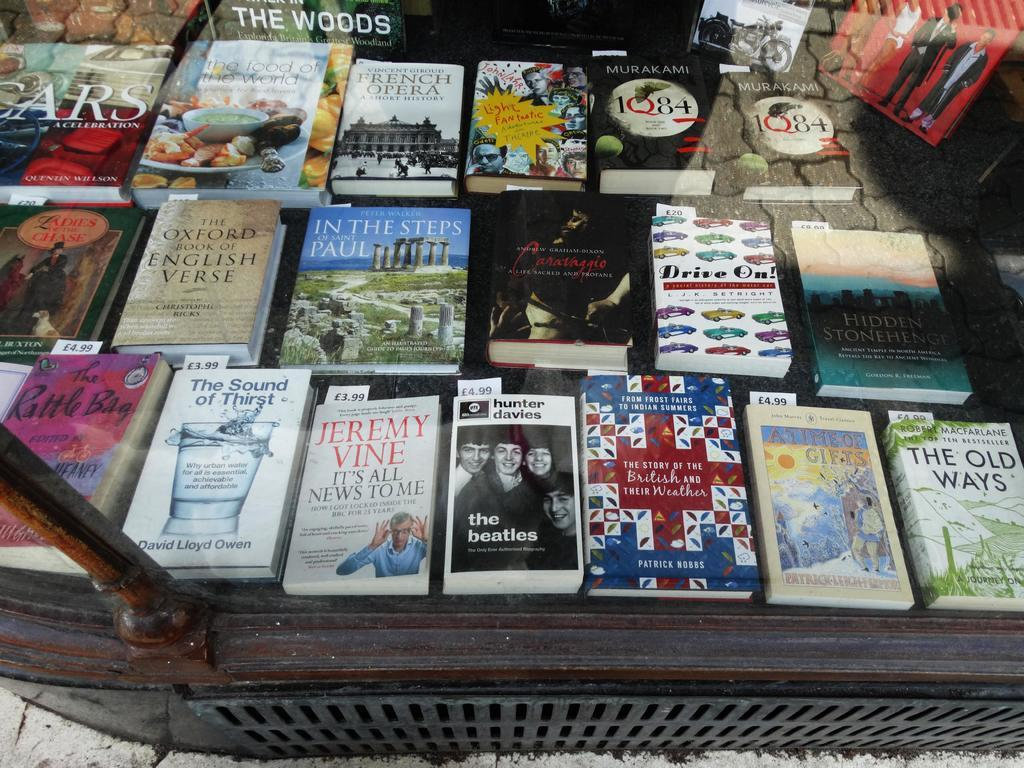<image>
Describe the image concisely. A book called The Old Ways among many books on a table. 